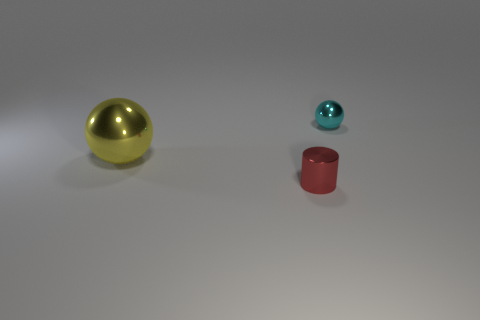Add 3 small red objects. How many objects exist? 6 Subtract all cylinders. How many objects are left? 2 Subtract all big metallic objects. Subtract all large green balls. How many objects are left? 2 Add 3 red cylinders. How many red cylinders are left? 4 Add 3 tiny red metal cylinders. How many tiny red metal cylinders exist? 4 Subtract 0 red blocks. How many objects are left? 3 